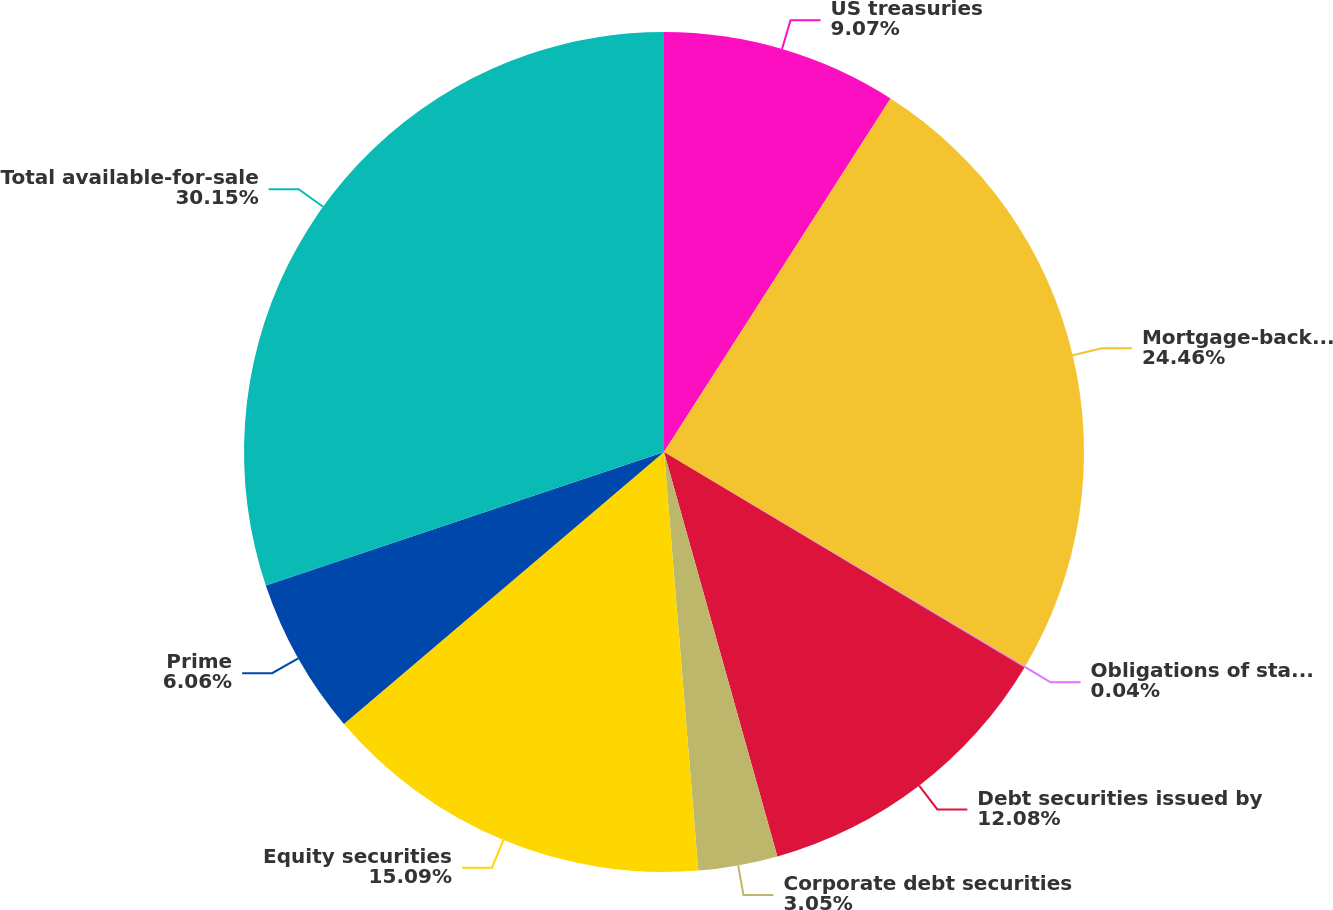<chart> <loc_0><loc_0><loc_500><loc_500><pie_chart><fcel>US treasuries<fcel>Mortgage-backed securities<fcel>Obligations of state and<fcel>Debt securities issued by<fcel>Corporate debt securities<fcel>Equity securities<fcel>Prime<fcel>Total available-for-sale<nl><fcel>9.07%<fcel>24.46%<fcel>0.04%<fcel>12.08%<fcel>3.05%<fcel>15.09%<fcel>6.06%<fcel>30.15%<nl></chart> 